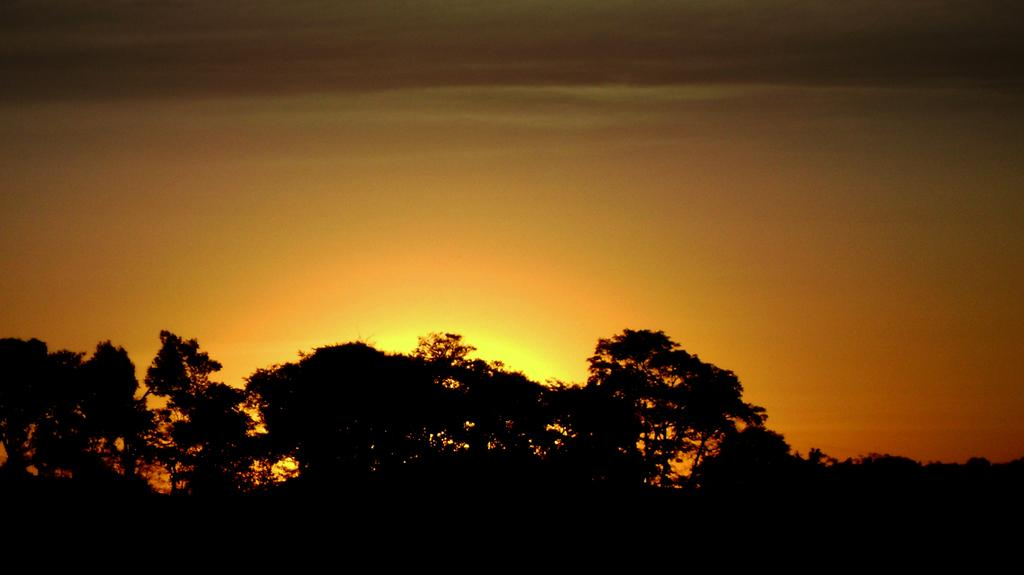What type of vegetation can be seen in the image? There are trees in the image. What is the color of the bottom part of the image? The bottom of the image is dark. What part of the natural environment is visible in the image? The sky is visible in the background of the image. What color is the crayon used to draw the trees in the image? There is no crayon present in the image, as the trees are real and not drawn. How is the toothbrush being used in the image? There is no toothbrush present in the image. 